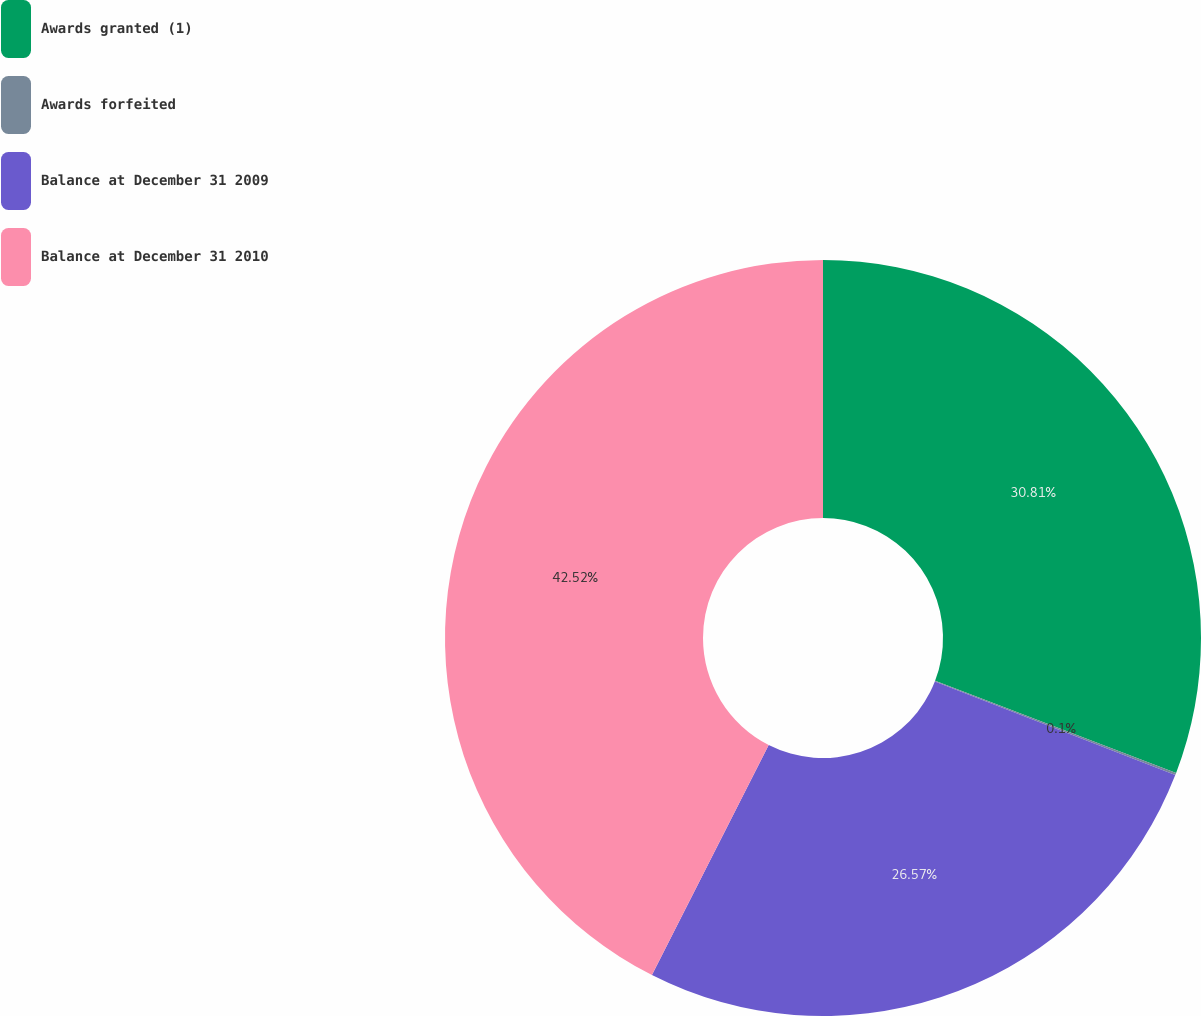<chart> <loc_0><loc_0><loc_500><loc_500><pie_chart><fcel>Awards granted (1)<fcel>Awards forfeited<fcel>Balance at December 31 2009<fcel>Balance at December 31 2010<nl><fcel>30.81%<fcel>0.1%<fcel>26.57%<fcel>42.53%<nl></chart> 